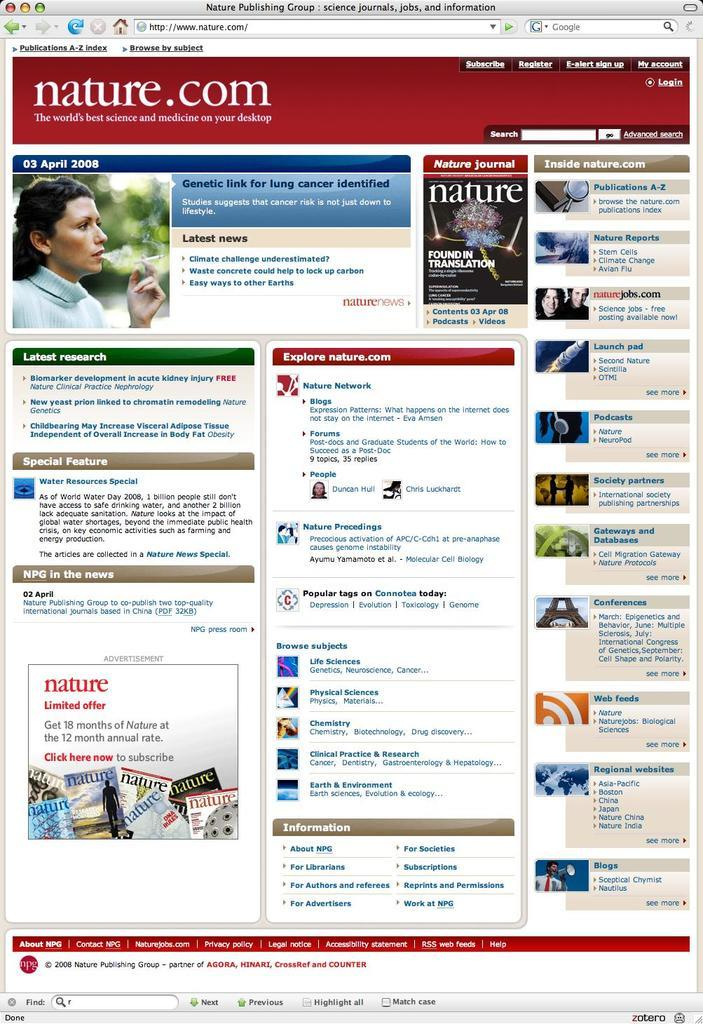What is present on both sides of the image? There are depictions of people on both the left and right sides of the image. What else can be found in the image besides the depictions of people? There is text in the image. What effect does the slip have on the learning process in the image? There is no mention of a slip or learning process in the image, so it is not possible to determine any effect. 